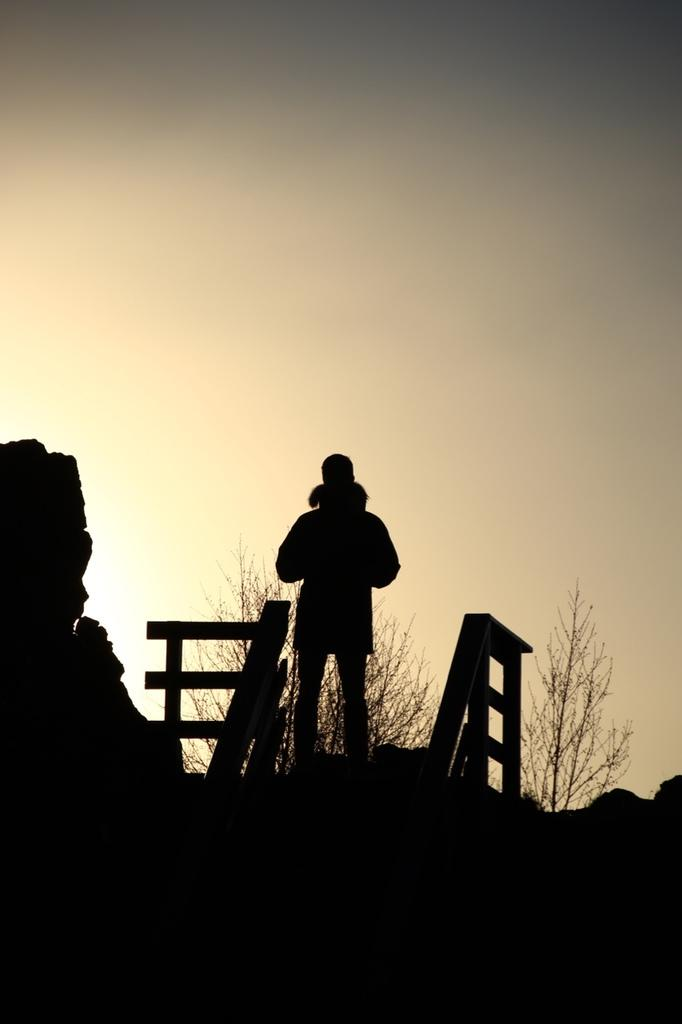What is the main subject in the image? There is a person standing in the image. What type of natural environment is visible in the image? There are trees in the image. What can be seen in the background of the image? The sky is visible in the background of the image. What type of stove is being used by the person in the image? There is no stove present in the image; it only features a person standing and trees in the background. 